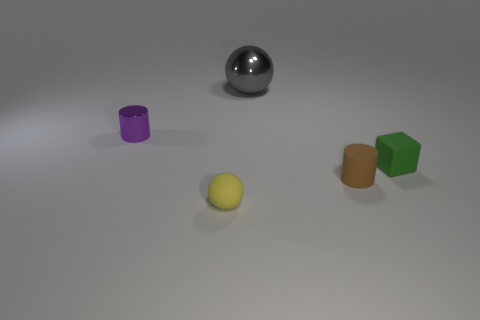There is a gray shiny sphere that is behind the tiny cylinder in front of the small purple thing; what number of balls are in front of it?
Give a very brief answer. 1. Are there fewer rubber blocks than small things?
Keep it short and to the point. Yes. Does the tiny rubber thing right of the tiny brown cylinder have the same shape as the thing that is behind the tiny purple object?
Your response must be concise. No. What is the color of the large thing?
Provide a succinct answer. Gray. What number of rubber objects are either cubes or small cylinders?
Your answer should be very brief. 2. What color is the other small object that is the same shape as the brown object?
Your response must be concise. Purple. Is there a tiny yellow thing?
Offer a very short reply. Yes. Is the material of the green block in front of the big ball the same as the purple cylinder that is behind the green thing?
Provide a short and direct response. No. What number of things are small things that are in front of the small block or small objects on the left side of the tiny rubber cylinder?
Your response must be concise. 3. There is a object that is both on the left side of the gray metal ball and in front of the green thing; what is its shape?
Offer a terse response. Sphere. 